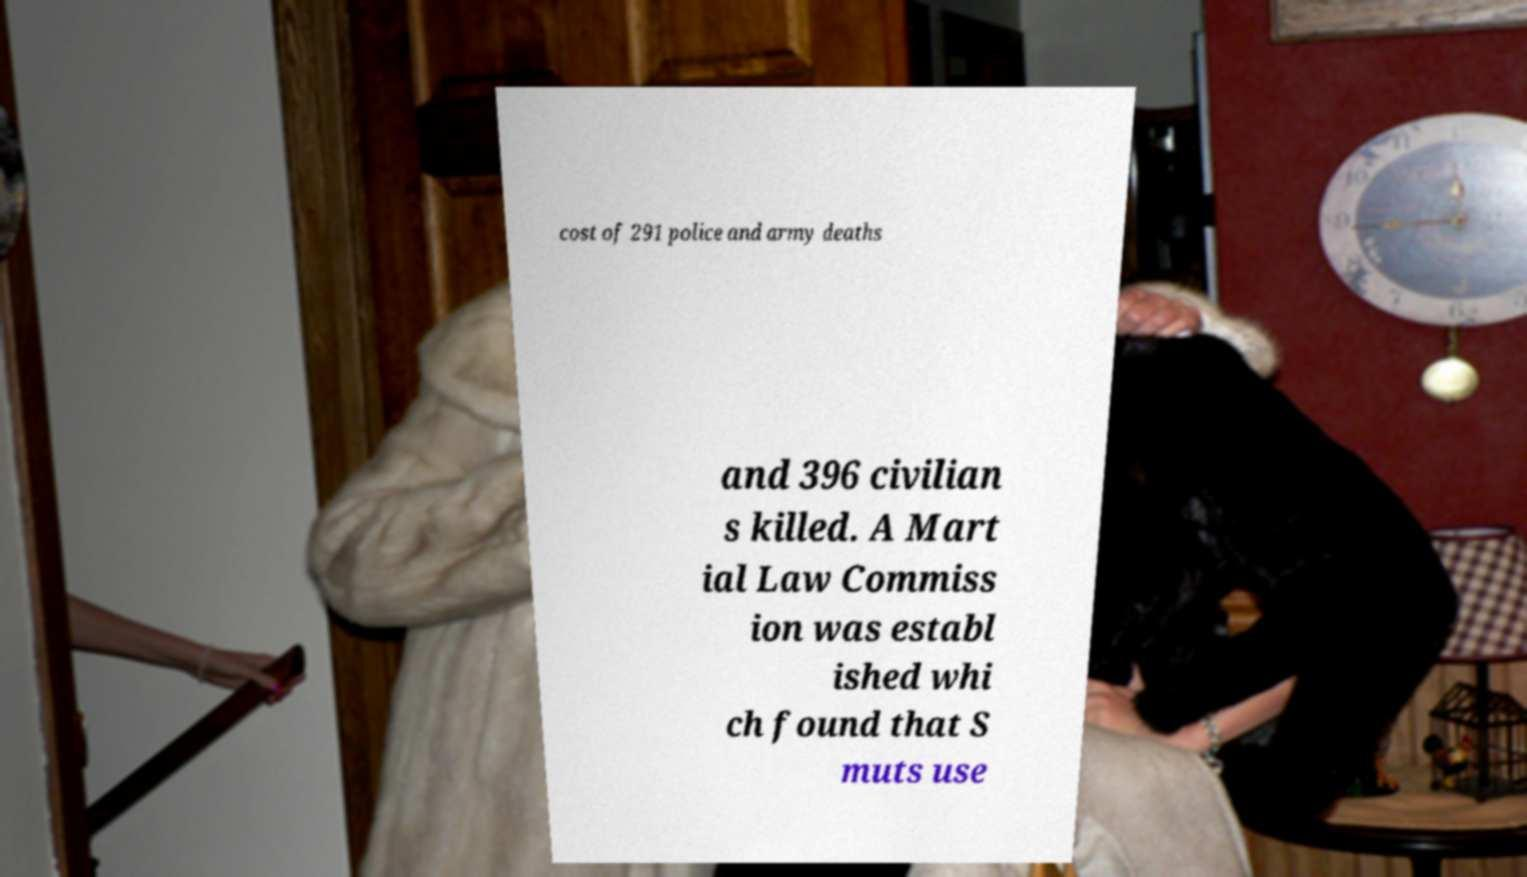Could you assist in decoding the text presented in this image and type it out clearly? cost of 291 police and army deaths and 396 civilian s killed. A Mart ial Law Commiss ion was establ ished whi ch found that S muts use 